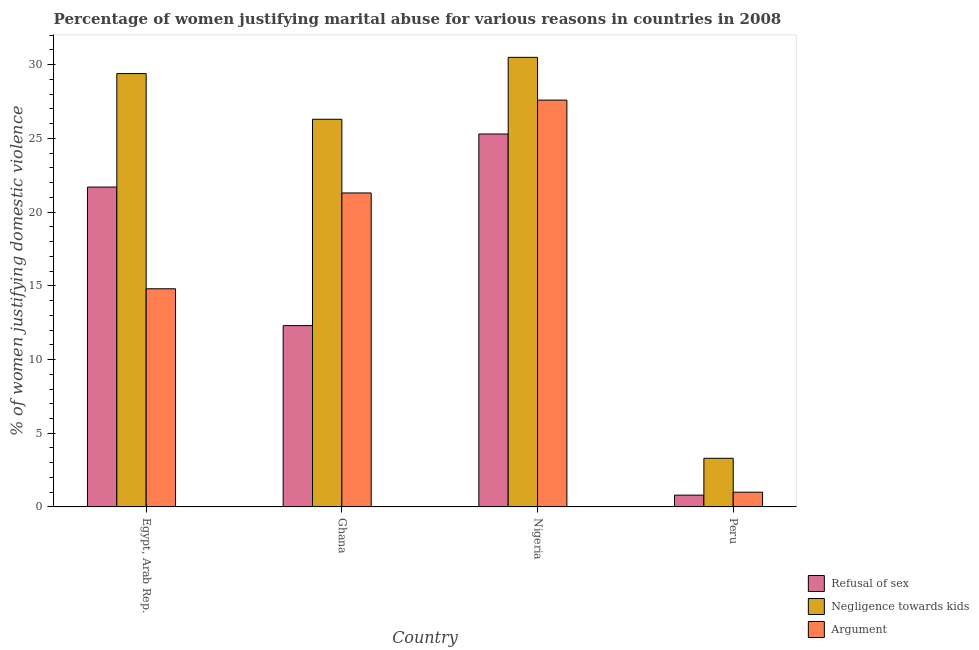How many different coloured bars are there?
Your answer should be very brief. 3. Are the number of bars on each tick of the X-axis equal?
Provide a short and direct response. Yes. How many bars are there on the 1st tick from the left?
Ensure brevity in your answer.  3. What is the label of the 4th group of bars from the left?
Ensure brevity in your answer.  Peru. In how many cases, is the number of bars for a given country not equal to the number of legend labels?
Your response must be concise. 0. What is the percentage of women justifying domestic violence due to negligence towards kids in Ghana?
Provide a succinct answer. 26.3. Across all countries, what is the maximum percentage of women justifying domestic violence due to arguments?
Give a very brief answer. 27.6. In which country was the percentage of women justifying domestic violence due to refusal of sex maximum?
Provide a succinct answer. Nigeria. In which country was the percentage of women justifying domestic violence due to negligence towards kids minimum?
Ensure brevity in your answer.  Peru. What is the total percentage of women justifying domestic violence due to negligence towards kids in the graph?
Your answer should be compact. 89.5. What is the difference between the percentage of women justifying domestic violence due to refusal of sex in Ghana and that in Nigeria?
Provide a short and direct response. -13. What is the difference between the percentage of women justifying domestic violence due to refusal of sex in Ghana and the percentage of women justifying domestic violence due to negligence towards kids in Nigeria?
Provide a succinct answer. -18.2. What is the average percentage of women justifying domestic violence due to refusal of sex per country?
Provide a succinct answer. 15.02. What is the ratio of the percentage of women justifying domestic violence due to refusal of sex in Egypt, Arab Rep. to that in Ghana?
Provide a short and direct response. 1.76. Is the percentage of women justifying domestic violence due to arguments in Nigeria less than that in Peru?
Offer a terse response. No. What is the difference between the highest and the second highest percentage of women justifying domestic violence due to arguments?
Offer a terse response. 6.3. What is the difference between the highest and the lowest percentage of women justifying domestic violence due to negligence towards kids?
Keep it short and to the point. 27.2. In how many countries, is the percentage of women justifying domestic violence due to refusal of sex greater than the average percentage of women justifying domestic violence due to refusal of sex taken over all countries?
Provide a short and direct response. 2. Is the sum of the percentage of women justifying domestic violence due to arguments in Egypt, Arab Rep. and Peru greater than the maximum percentage of women justifying domestic violence due to refusal of sex across all countries?
Offer a terse response. No. What does the 3rd bar from the left in Peru represents?
Provide a succinct answer. Argument. What does the 2nd bar from the right in Nigeria represents?
Your response must be concise. Negligence towards kids. How many bars are there?
Make the answer very short. 12. Are the values on the major ticks of Y-axis written in scientific E-notation?
Provide a succinct answer. No. Does the graph contain grids?
Your response must be concise. No. What is the title of the graph?
Ensure brevity in your answer.  Percentage of women justifying marital abuse for various reasons in countries in 2008. Does "Ages 60+" appear as one of the legend labels in the graph?
Your answer should be compact. No. What is the label or title of the X-axis?
Offer a very short reply. Country. What is the label or title of the Y-axis?
Offer a terse response. % of women justifying domestic violence. What is the % of women justifying domestic violence of Refusal of sex in Egypt, Arab Rep.?
Offer a terse response. 21.7. What is the % of women justifying domestic violence of Negligence towards kids in Egypt, Arab Rep.?
Make the answer very short. 29.4. What is the % of women justifying domestic violence of Negligence towards kids in Ghana?
Ensure brevity in your answer.  26.3. What is the % of women justifying domestic violence in Argument in Ghana?
Provide a succinct answer. 21.3. What is the % of women justifying domestic violence in Refusal of sex in Nigeria?
Give a very brief answer. 25.3. What is the % of women justifying domestic violence of Negligence towards kids in Nigeria?
Offer a very short reply. 30.5. What is the % of women justifying domestic violence in Argument in Nigeria?
Your answer should be compact. 27.6. What is the % of women justifying domestic violence of Negligence towards kids in Peru?
Ensure brevity in your answer.  3.3. Across all countries, what is the maximum % of women justifying domestic violence in Refusal of sex?
Your response must be concise. 25.3. Across all countries, what is the maximum % of women justifying domestic violence in Negligence towards kids?
Offer a very short reply. 30.5. Across all countries, what is the maximum % of women justifying domestic violence of Argument?
Your answer should be very brief. 27.6. Across all countries, what is the minimum % of women justifying domestic violence of Refusal of sex?
Offer a very short reply. 0.8. Across all countries, what is the minimum % of women justifying domestic violence in Negligence towards kids?
Your response must be concise. 3.3. Across all countries, what is the minimum % of women justifying domestic violence of Argument?
Provide a short and direct response. 1. What is the total % of women justifying domestic violence of Refusal of sex in the graph?
Ensure brevity in your answer.  60.1. What is the total % of women justifying domestic violence in Negligence towards kids in the graph?
Make the answer very short. 89.5. What is the total % of women justifying domestic violence of Argument in the graph?
Keep it short and to the point. 64.7. What is the difference between the % of women justifying domestic violence in Refusal of sex in Egypt, Arab Rep. and that in Ghana?
Your response must be concise. 9.4. What is the difference between the % of women justifying domestic violence in Refusal of sex in Egypt, Arab Rep. and that in Nigeria?
Give a very brief answer. -3.6. What is the difference between the % of women justifying domestic violence in Refusal of sex in Egypt, Arab Rep. and that in Peru?
Offer a very short reply. 20.9. What is the difference between the % of women justifying domestic violence of Negligence towards kids in Egypt, Arab Rep. and that in Peru?
Offer a terse response. 26.1. What is the difference between the % of women justifying domestic violence in Negligence towards kids in Ghana and that in Peru?
Ensure brevity in your answer.  23. What is the difference between the % of women justifying domestic violence of Argument in Ghana and that in Peru?
Your answer should be very brief. 20.3. What is the difference between the % of women justifying domestic violence of Refusal of sex in Nigeria and that in Peru?
Your response must be concise. 24.5. What is the difference between the % of women justifying domestic violence of Negligence towards kids in Nigeria and that in Peru?
Your response must be concise. 27.2. What is the difference between the % of women justifying domestic violence of Argument in Nigeria and that in Peru?
Make the answer very short. 26.6. What is the difference between the % of women justifying domestic violence in Refusal of sex in Egypt, Arab Rep. and the % of women justifying domestic violence in Negligence towards kids in Ghana?
Provide a short and direct response. -4.6. What is the difference between the % of women justifying domestic violence in Refusal of sex in Egypt, Arab Rep. and the % of women justifying domestic violence in Negligence towards kids in Nigeria?
Provide a succinct answer. -8.8. What is the difference between the % of women justifying domestic violence of Negligence towards kids in Egypt, Arab Rep. and the % of women justifying domestic violence of Argument in Nigeria?
Offer a very short reply. 1.8. What is the difference between the % of women justifying domestic violence of Refusal of sex in Egypt, Arab Rep. and the % of women justifying domestic violence of Argument in Peru?
Provide a succinct answer. 20.7. What is the difference between the % of women justifying domestic violence in Negligence towards kids in Egypt, Arab Rep. and the % of women justifying domestic violence in Argument in Peru?
Your answer should be very brief. 28.4. What is the difference between the % of women justifying domestic violence in Refusal of sex in Ghana and the % of women justifying domestic violence in Negligence towards kids in Nigeria?
Keep it short and to the point. -18.2. What is the difference between the % of women justifying domestic violence of Refusal of sex in Ghana and the % of women justifying domestic violence of Argument in Nigeria?
Offer a very short reply. -15.3. What is the difference between the % of women justifying domestic violence in Negligence towards kids in Ghana and the % of women justifying domestic violence in Argument in Nigeria?
Your response must be concise. -1.3. What is the difference between the % of women justifying domestic violence in Refusal of sex in Ghana and the % of women justifying domestic violence in Negligence towards kids in Peru?
Give a very brief answer. 9. What is the difference between the % of women justifying domestic violence in Negligence towards kids in Ghana and the % of women justifying domestic violence in Argument in Peru?
Give a very brief answer. 25.3. What is the difference between the % of women justifying domestic violence in Refusal of sex in Nigeria and the % of women justifying domestic violence in Negligence towards kids in Peru?
Offer a terse response. 22. What is the difference between the % of women justifying domestic violence of Refusal of sex in Nigeria and the % of women justifying domestic violence of Argument in Peru?
Offer a very short reply. 24.3. What is the difference between the % of women justifying domestic violence in Negligence towards kids in Nigeria and the % of women justifying domestic violence in Argument in Peru?
Provide a short and direct response. 29.5. What is the average % of women justifying domestic violence of Refusal of sex per country?
Your answer should be very brief. 15.03. What is the average % of women justifying domestic violence in Negligence towards kids per country?
Keep it short and to the point. 22.38. What is the average % of women justifying domestic violence of Argument per country?
Provide a short and direct response. 16.18. What is the difference between the % of women justifying domestic violence in Refusal of sex and % of women justifying domestic violence in Negligence towards kids in Egypt, Arab Rep.?
Ensure brevity in your answer.  -7.7. What is the difference between the % of women justifying domestic violence of Refusal of sex and % of women justifying domestic violence of Negligence towards kids in Ghana?
Give a very brief answer. -14. What is the difference between the % of women justifying domestic violence in Refusal of sex and % of women justifying domestic violence in Argument in Ghana?
Keep it short and to the point. -9. What is the difference between the % of women justifying domestic violence of Negligence towards kids and % of women justifying domestic violence of Argument in Ghana?
Your answer should be very brief. 5. What is the difference between the % of women justifying domestic violence of Refusal of sex and % of women justifying domestic violence of Argument in Nigeria?
Offer a terse response. -2.3. What is the difference between the % of women justifying domestic violence in Refusal of sex and % of women justifying domestic violence in Negligence towards kids in Peru?
Ensure brevity in your answer.  -2.5. What is the difference between the % of women justifying domestic violence of Negligence towards kids and % of women justifying domestic violence of Argument in Peru?
Your answer should be very brief. 2.3. What is the ratio of the % of women justifying domestic violence in Refusal of sex in Egypt, Arab Rep. to that in Ghana?
Provide a succinct answer. 1.76. What is the ratio of the % of women justifying domestic violence in Negligence towards kids in Egypt, Arab Rep. to that in Ghana?
Your answer should be very brief. 1.12. What is the ratio of the % of women justifying domestic violence of Argument in Egypt, Arab Rep. to that in Ghana?
Your response must be concise. 0.69. What is the ratio of the % of women justifying domestic violence in Refusal of sex in Egypt, Arab Rep. to that in Nigeria?
Offer a very short reply. 0.86. What is the ratio of the % of women justifying domestic violence of Negligence towards kids in Egypt, Arab Rep. to that in Nigeria?
Your answer should be compact. 0.96. What is the ratio of the % of women justifying domestic violence in Argument in Egypt, Arab Rep. to that in Nigeria?
Your response must be concise. 0.54. What is the ratio of the % of women justifying domestic violence of Refusal of sex in Egypt, Arab Rep. to that in Peru?
Offer a very short reply. 27.12. What is the ratio of the % of women justifying domestic violence in Negligence towards kids in Egypt, Arab Rep. to that in Peru?
Make the answer very short. 8.91. What is the ratio of the % of women justifying domestic violence in Argument in Egypt, Arab Rep. to that in Peru?
Offer a very short reply. 14.8. What is the ratio of the % of women justifying domestic violence of Refusal of sex in Ghana to that in Nigeria?
Your response must be concise. 0.49. What is the ratio of the % of women justifying domestic violence of Negligence towards kids in Ghana to that in Nigeria?
Your answer should be very brief. 0.86. What is the ratio of the % of women justifying domestic violence of Argument in Ghana to that in Nigeria?
Give a very brief answer. 0.77. What is the ratio of the % of women justifying domestic violence in Refusal of sex in Ghana to that in Peru?
Ensure brevity in your answer.  15.38. What is the ratio of the % of women justifying domestic violence in Negligence towards kids in Ghana to that in Peru?
Make the answer very short. 7.97. What is the ratio of the % of women justifying domestic violence of Argument in Ghana to that in Peru?
Keep it short and to the point. 21.3. What is the ratio of the % of women justifying domestic violence in Refusal of sex in Nigeria to that in Peru?
Give a very brief answer. 31.62. What is the ratio of the % of women justifying domestic violence of Negligence towards kids in Nigeria to that in Peru?
Your response must be concise. 9.24. What is the ratio of the % of women justifying domestic violence in Argument in Nigeria to that in Peru?
Provide a short and direct response. 27.6. What is the difference between the highest and the second highest % of women justifying domestic violence in Argument?
Your answer should be very brief. 6.3. What is the difference between the highest and the lowest % of women justifying domestic violence in Negligence towards kids?
Keep it short and to the point. 27.2. What is the difference between the highest and the lowest % of women justifying domestic violence of Argument?
Provide a succinct answer. 26.6. 